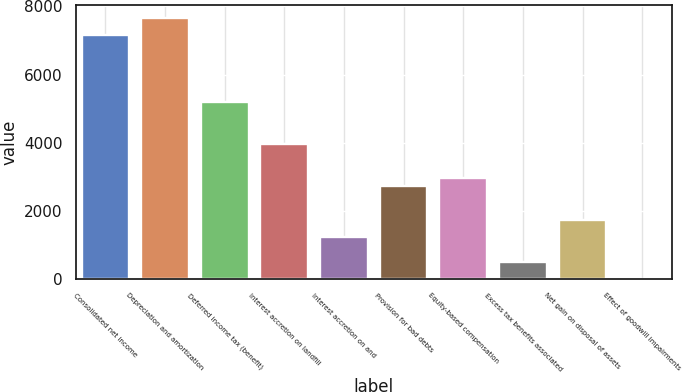<chart> <loc_0><loc_0><loc_500><loc_500><bar_chart><fcel>Consolidated net income<fcel>Depreciation and amortization<fcel>Deferred income tax (benefit)<fcel>Interest accretion on landfill<fcel>Interest accretion on and<fcel>Provision for bad debts<fcel>Equity-based compensation<fcel>Excess tax benefits associated<fcel>Net gain on disposal of assets<fcel>Effect of goodwill impairments<nl><fcel>7158.2<fcel>7651.8<fcel>5183.8<fcel>3949.8<fcel>1235<fcel>2715.8<fcel>2962.6<fcel>494.6<fcel>1728.6<fcel>1<nl></chart> 